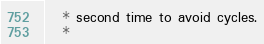<code> <loc_0><loc_0><loc_500><loc_500><_Scala_>   * second time to avoid cycles.
   * </code> 